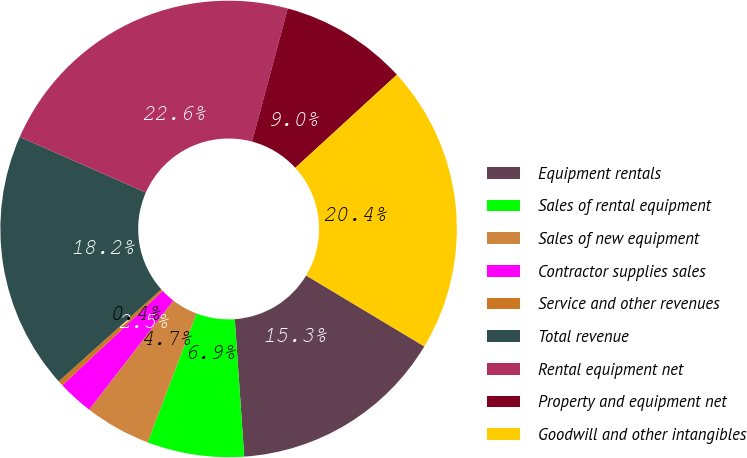<chart> <loc_0><loc_0><loc_500><loc_500><pie_chart><fcel>Equipment rentals<fcel>Sales of rental equipment<fcel>Sales of new equipment<fcel>Contractor supplies sales<fcel>Service and other revenues<fcel>Total revenue<fcel>Rental equipment net<fcel>Property and equipment net<fcel>Goodwill and other intangibles<nl><fcel>15.31%<fcel>6.86%<fcel>4.69%<fcel>2.53%<fcel>0.37%<fcel>18.24%<fcel>22.57%<fcel>9.02%<fcel>20.41%<nl></chart> 